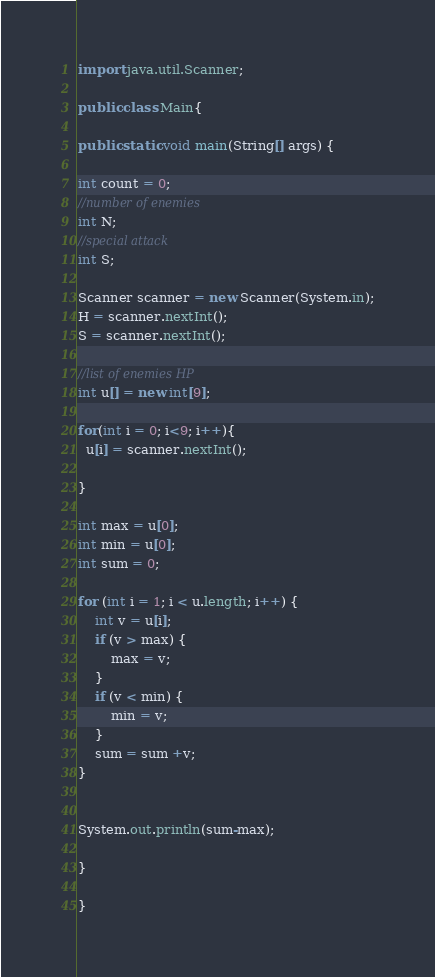Convert code to text. <code><loc_0><loc_0><loc_500><loc_500><_Java_>import java.util.Scanner;
 
public class Main{
 
public static void main(String[] args) {
 
int count = 0;
//number of enemies
int N;
//special attack
int S;
 
Scanner scanner = new Scanner(System.in);
H = scanner.nextInt();
S = scanner.nextInt();

//list of enemies HP
int u[] = new int[9];
  
for(int i = 0; i<9; i++){
  u[i] = scanner.nextInt();
  
}

int max = u[0];
int min = u[0];
int sum = 0;

for (int i = 1; i < u.length; i++) {
    int v = u[i];
    if (v > max) {
        max = v;
    }
    if (v < min) {
        min = v;
    }
    sum = sum +v;
}

  
System.out.println(sum-max);
  
}
  
}</code> 